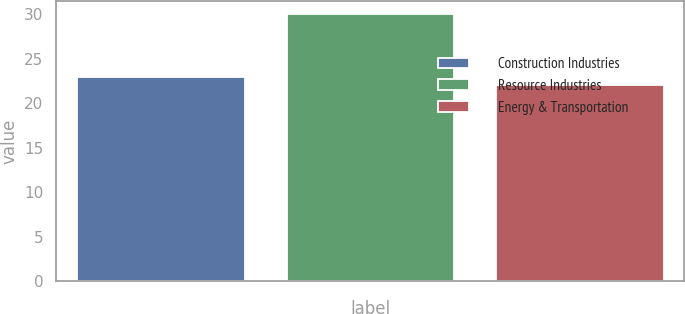Convert chart to OTSL. <chart><loc_0><loc_0><loc_500><loc_500><bar_chart><fcel>Construction Industries<fcel>Resource Industries<fcel>Energy & Transportation<nl><fcel>23<fcel>30<fcel>22<nl></chart> 